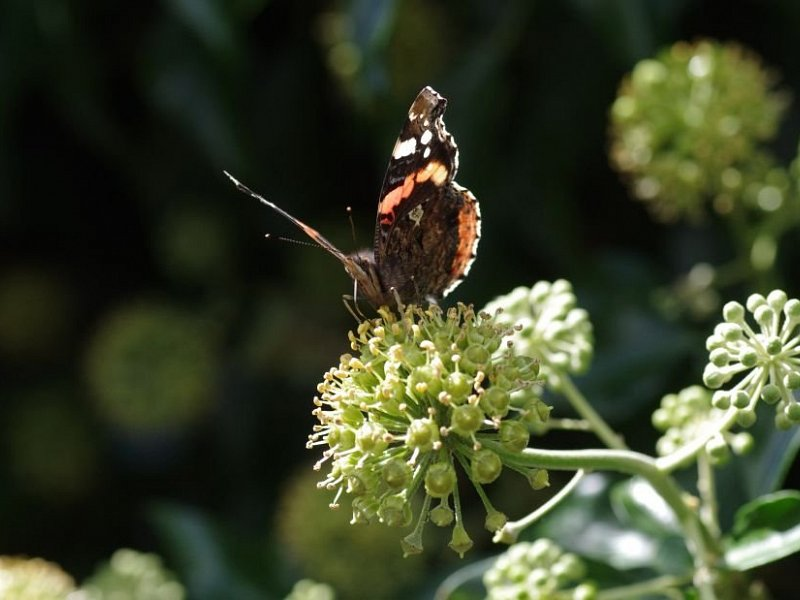Imagine the butterfly could talk. What story would it tell about its day? If the butterfly could talk, it might tell a delightful story about its day, fluttering from flower to flower in a quest for the sweetest nectar. It would describe the gentle warmth of the sun as it moved through the garden, the subtle fragrances of each bloom, and the brushes with other creatures. Perhaps it found a particularly abundant flower patch that filled it with energy. Alongside this busy and productive day, it also had to stay vigilant for predators, always ready to flutter away at the first sign of danger. What might the butterfly see during its flight around the garden? During its flight around the garden, the butterfly would likely see a vibrant and bustling ecosystem. It would notice an array of colorful flowers, each with different shapes and scents. There might be other insects, such as bees and dragonflies, also busy with their daily activities. The butterfly would witness the delicate movements of leaves swaying in the breeze and perhaps even spot a bird perched on a branch, singing a morning song. It could also observe humans tending the garden or children playing nearby, adding a lively and dynamic atmosphere to the garden. 